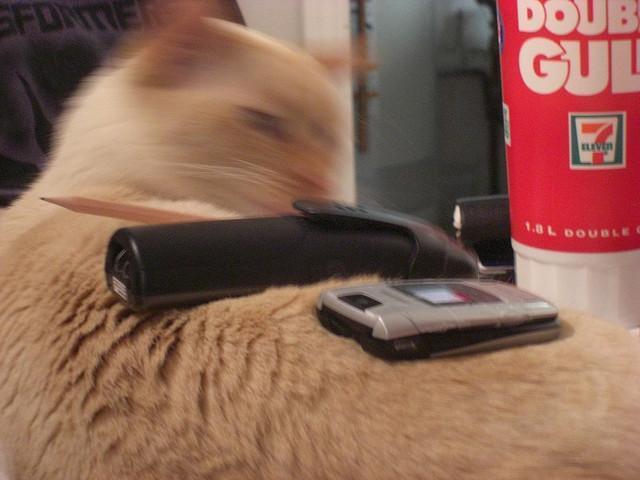How many people can we see?
Give a very brief answer. 0. 